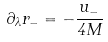Convert formula to latex. <formula><loc_0><loc_0><loc_500><loc_500>\partial _ { \lambda } r _ { - } = - \frac { u _ { - } } { 4 M }</formula> 